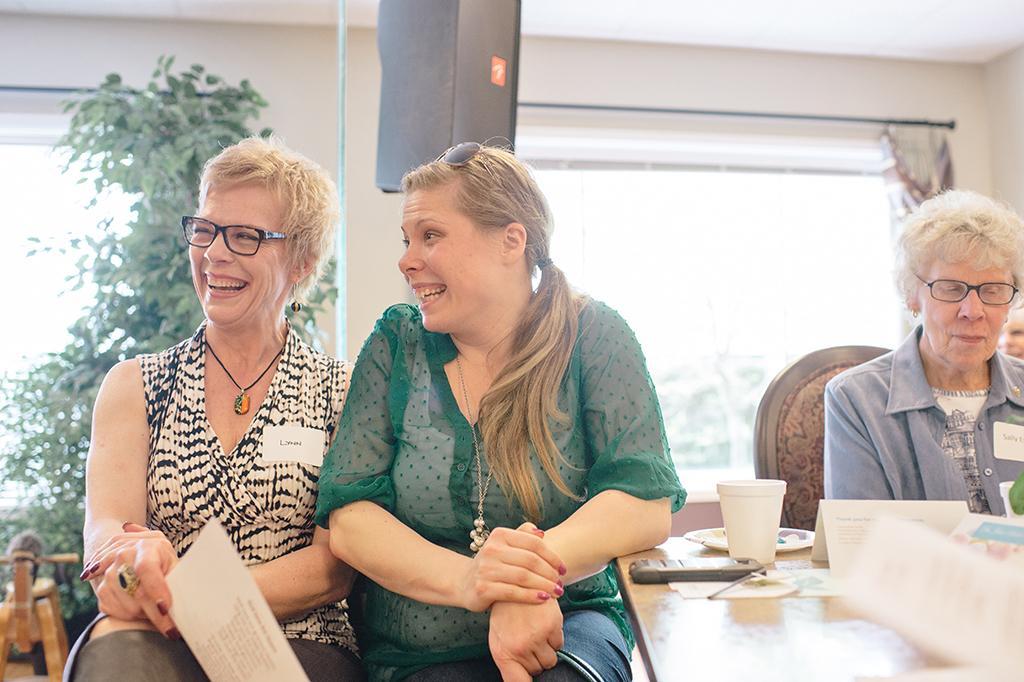Can you describe this image briefly? In the image I can see two women and they are smiling. I can see a woman on the left side is holding a paper in her right hand. I can see a plant on the left side. I can see a mobile phone, a plastic glass and papers are kept on the wooden table which is on the bottom right side. There is another woman sitting on the chair and she is on the right side. This is looking like a speaker at the top of the picture. In the background, I can see the glass window and curtain. 